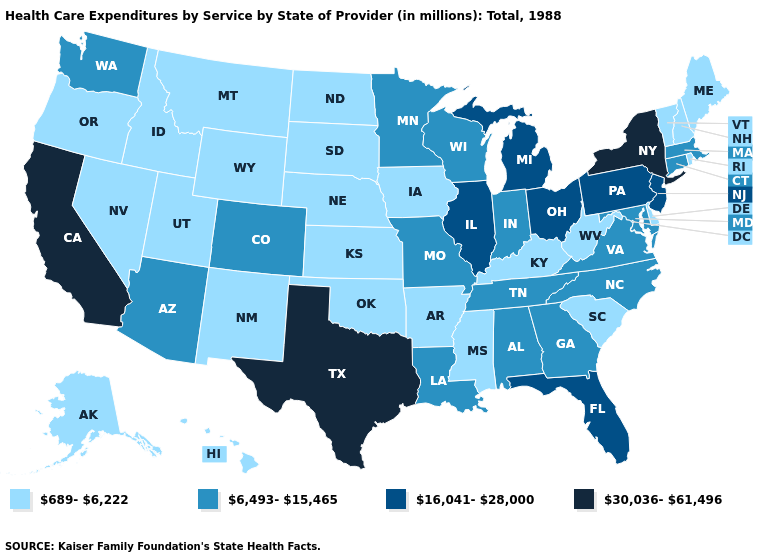Name the states that have a value in the range 689-6,222?
Write a very short answer. Alaska, Arkansas, Delaware, Hawaii, Idaho, Iowa, Kansas, Kentucky, Maine, Mississippi, Montana, Nebraska, Nevada, New Hampshire, New Mexico, North Dakota, Oklahoma, Oregon, Rhode Island, South Carolina, South Dakota, Utah, Vermont, West Virginia, Wyoming. Name the states that have a value in the range 689-6,222?
Give a very brief answer. Alaska, Arkansas, Delaware, Hawaii, Idaho, Iowa, Kansas, Kentucky, Maine, Mississippi, Montana, Nebraska, Nevada, New Hampshire, New Mexico, North Dakota, Oklahoma, Oregon, Rhode Island, South Carolina, South Dakota, Utah, Vermont, West Virginia, Wyoming. Name the states that have a value in the range 689-6,222?
Write a very short answer. Alaska, Arkansas, Delaware, Hawaii, Idaho, Iowa, Kansas, Kentucky, Maine, Mississippi, Montana, Nebraska, Nevada, New Hampshire, New Mexico, North Dakota, Oklahoma, Oregon, Rhode Island, South Carolina, South Dakota, Utah, Vermont, West Virginia, Wyoming. Name the states that have a value in the range 6,493-15,465?
Keep it brief. Alabama, Arizona, Colorado, Connecticut, Georgia, Indiana, Louisiana, Maryland, Massachusetts, Minnesota, Missouri, North Carolina, Tennessee, Virginia, Washington, Wisconsin. Among the states that border Oklahoma , which have the highest value?
Quick response, please. Texas. Does New York have the highest value in the USA?
Be succinct. Yes. What is the value of Arizona?
Short answer required. 6,493-15,465. Among the states that border Iowa , which have the highest value?
Give a very brief answer. Illinois. Does Virginia have a lower value than Wisconsin?
Be succinct. No. What is the value of California?
Give a very brief answer. 30,036-61,496. Among the states that border Indiana , which have the lowest value?
Give a very brief answer. Kentucky. Among the states that border Connecticut , which have the lowest value?
Quick response, please. Rhode Island. What is the lowest value in the USA?
Give a very brief answer. 689-6,222. What is the highest value in states that border Utah?
Concise answer only. 6,493-15,465. Does the first symbol in the legend represent the smallest category?
Keep it brief. Yes. 